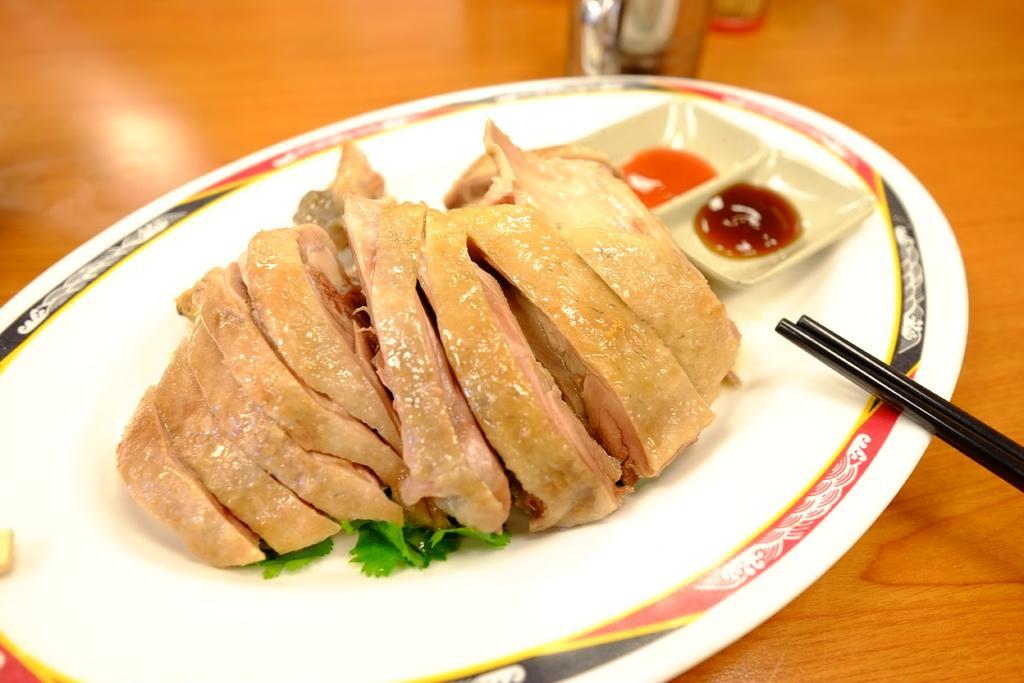Describe this image in one or two sentences. Here we can see a plate full of meat and sauces and chopsticks present on a table 